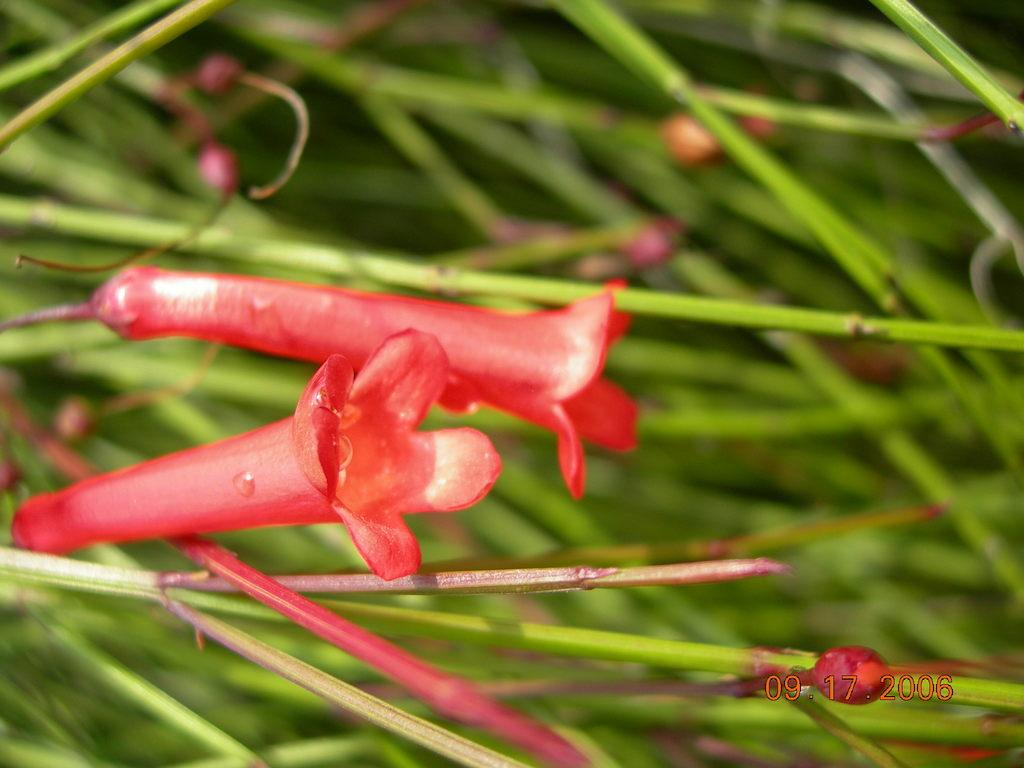What type of plant life is present in the image? There are flowers, buds, and stems in the image. Can you describe the different parts of the plants in the image? The flowers are the colorful parts of the plants, the buds are the unopened flowers, and the stems are the long, thin parts that connect the flowers and buds to the ground. Is there any text or numbers visible in the image? Yes, there is a date written in the bottom right side of the image. How many trees are covered in snow in the image? There are no trees or snow present in the image; it features flowers, buds, and stems. What type of bite can be seen on one of the flowers in the image? There is no bite visible on any of the flowers in the image. 